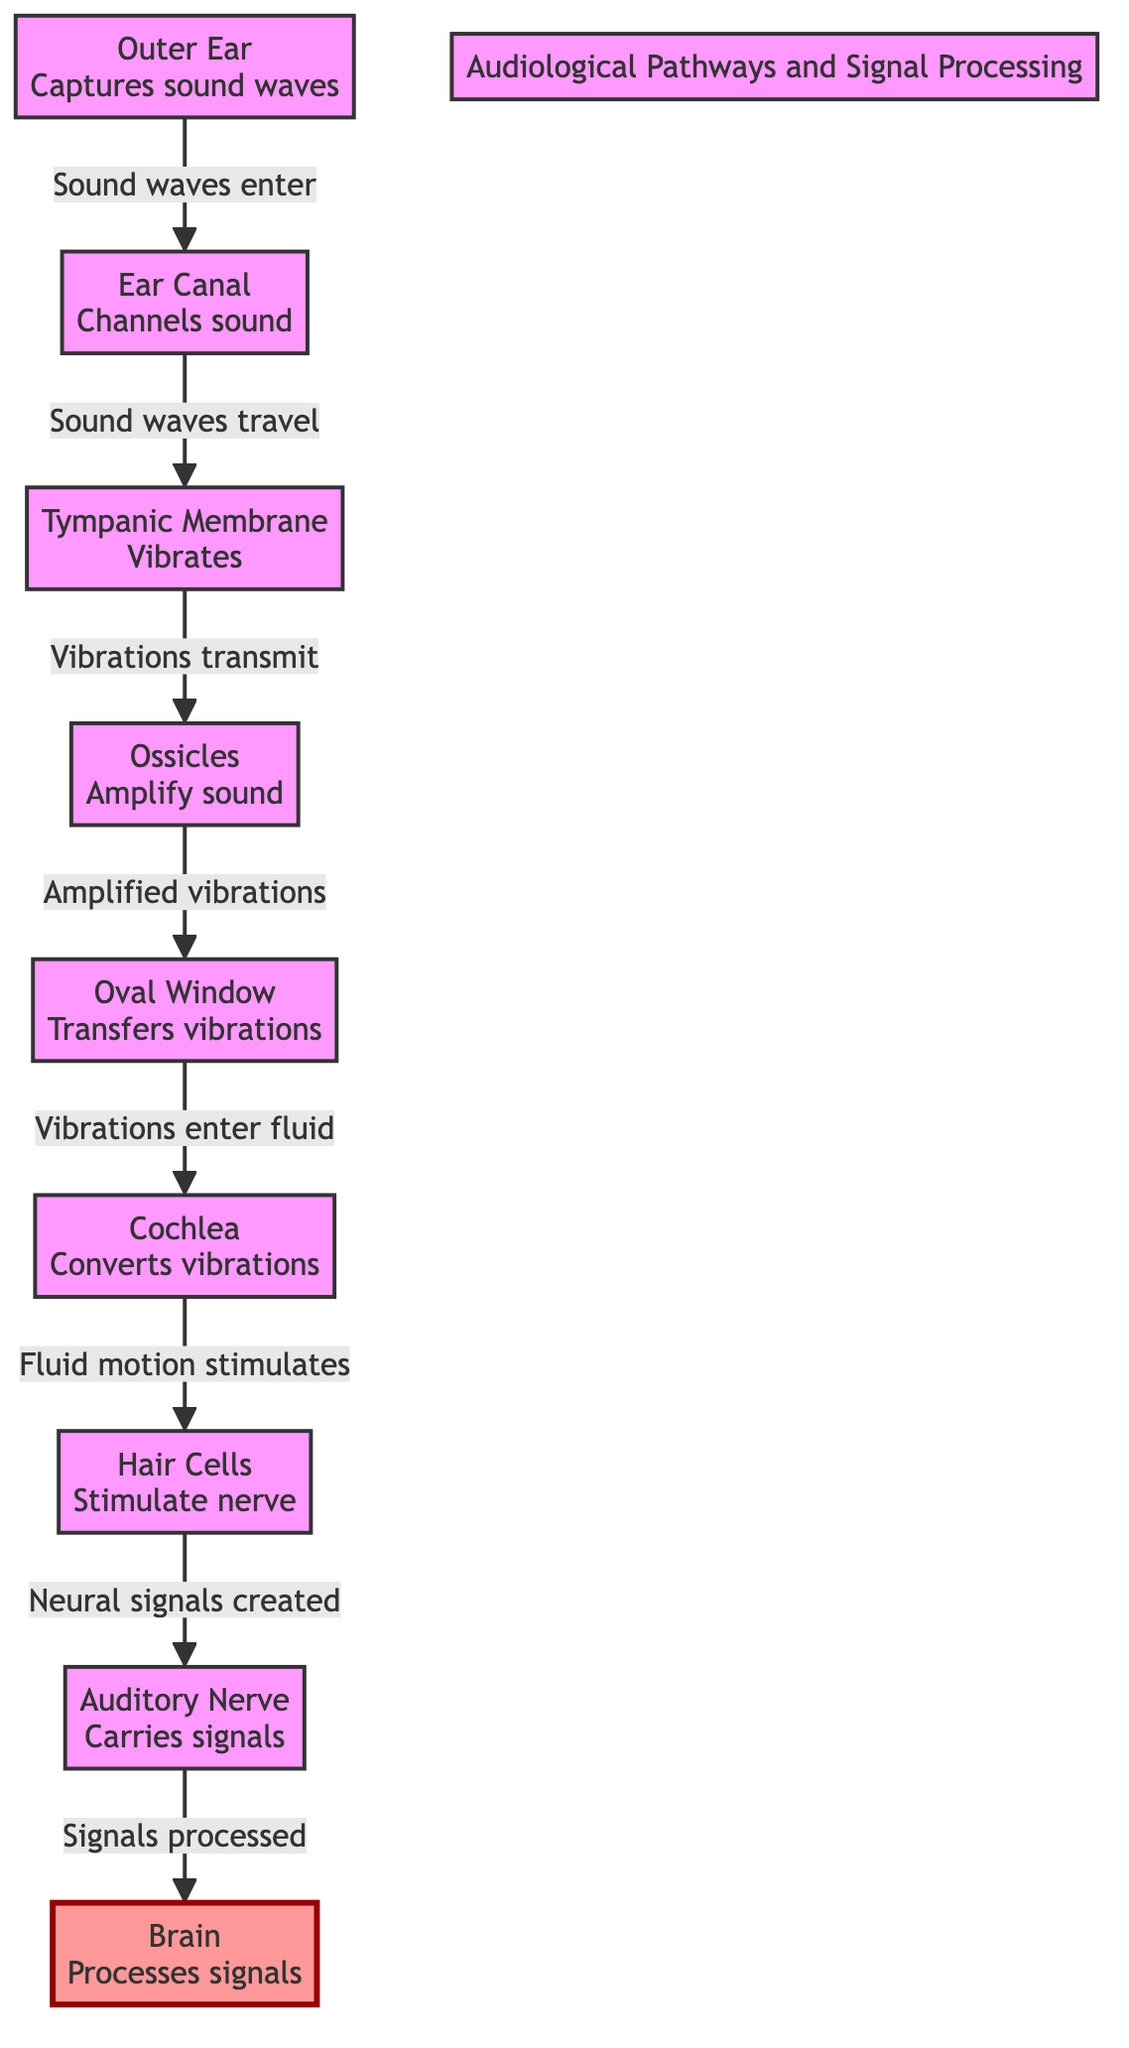What is the first component of the audiological pathway? The diagram starts with the outer ear, which captures sound waves as the first component in the pathway.
Answer: Outer Ear How many main components are involved in the signal processing? The diagram lists eight main components through which the sound passes and is processed, from the outer ear to the brain.
Answer: Eight What happens at the tympanic membrane? According to the diagram, the tympanic membrane vibrates when sound waves travel through the ear canal, which is its primary function.
Answer: Vibrates What role do the ossicles play in the auditory pathway? The ossicles amplify the vibrations received from the tympanic membrane, which enhances the sound signal before it moves to the oval window.
Answer: Amplify sound How does the cochlea contribute to hearing? The cochlea's function involves converting vibrations into neural signals by stimulating the hair cells, making it essential for processing sound.
Answer: Converts vibrations What is the final destination of the signals carried by the auditory nerve? The auditory nerve carries signals to the brain, where they are processed according to the diagram.
Answer: Brain Why is the role of hair cells crucial in hearing? Hair cells stimulate the nerve by converting the fluid motion from the cochlea into neural signals, which is necessary for transmitting sound information to the brain.
Answer: Stimulate nerve What happens after fluid motion stimulates hair cells? Once the hair cells are stimulated, they create neural signals that are carried away by the auditory nerve to be processed in the brain.
Answer: Neural signals created 